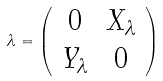<formula> <loc_0><loc_0><loc_500><loc_500>\lambda = \left ( \begin{array} { c c } 0 & X _ { \lambda } \\ Y _ { \lambda } & 0 \\ \end{array} \right )</formula> 